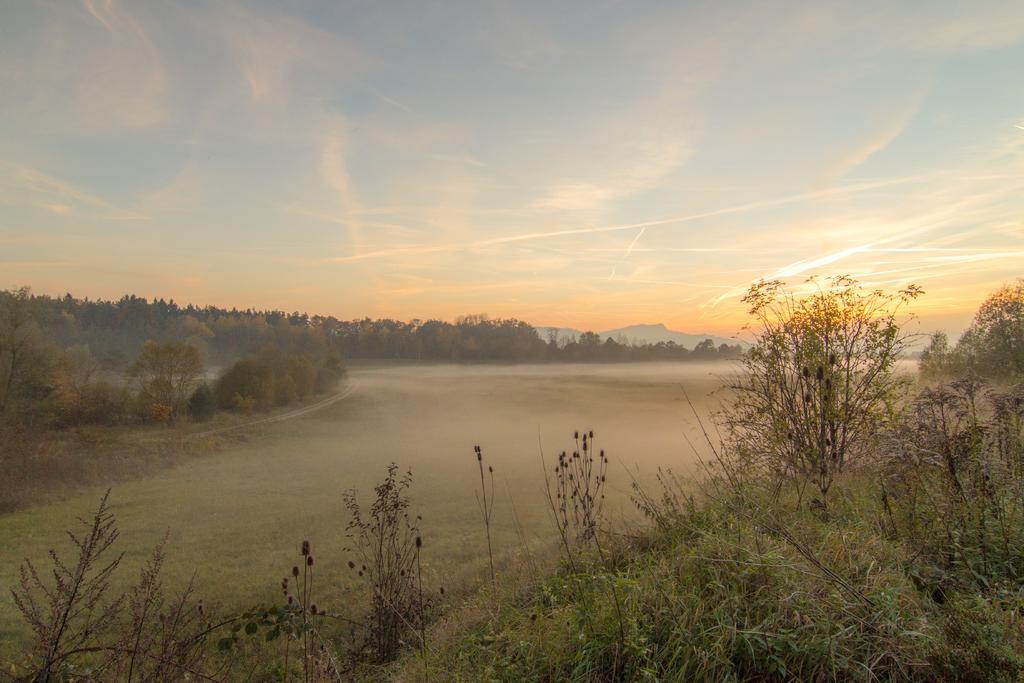In one or two sentences, can you explain what this image depicts? In this image we can see plants and trees. In the background there are hills. Also there is sky with clouds. 